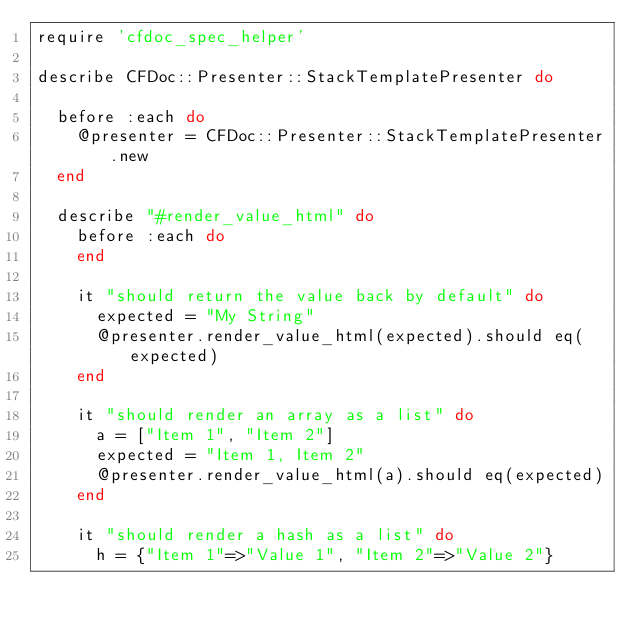<code> <loc_0><loc_0><loc_500><loc_500><_Ruby_>require 'cfdoc_spec_helper'

describe CFDoc::Presenter::StackTemplatePresenter do

  before :each do
    @presenter = CFDoc::Presenter::StackTemplatePresenter.new
  end

  describe "#render_value_html" do
    before :each do
    end

    it "should return the value back by default" do
      expected = "My String"
      @presenter.render_value_html(expected).should eq(expected)
    end

    it "should render an array as a list" do
      a = ["Item 1", "Item 2"]
      expected = "Item 1, Item 2"
      @presenter.render_value_html(a).should eq(expected)
    end

    it "should render a hash as a list" do
      h = {"Item 1"=>"Value 1", "Item 2"=>"Value 2"}</code> 